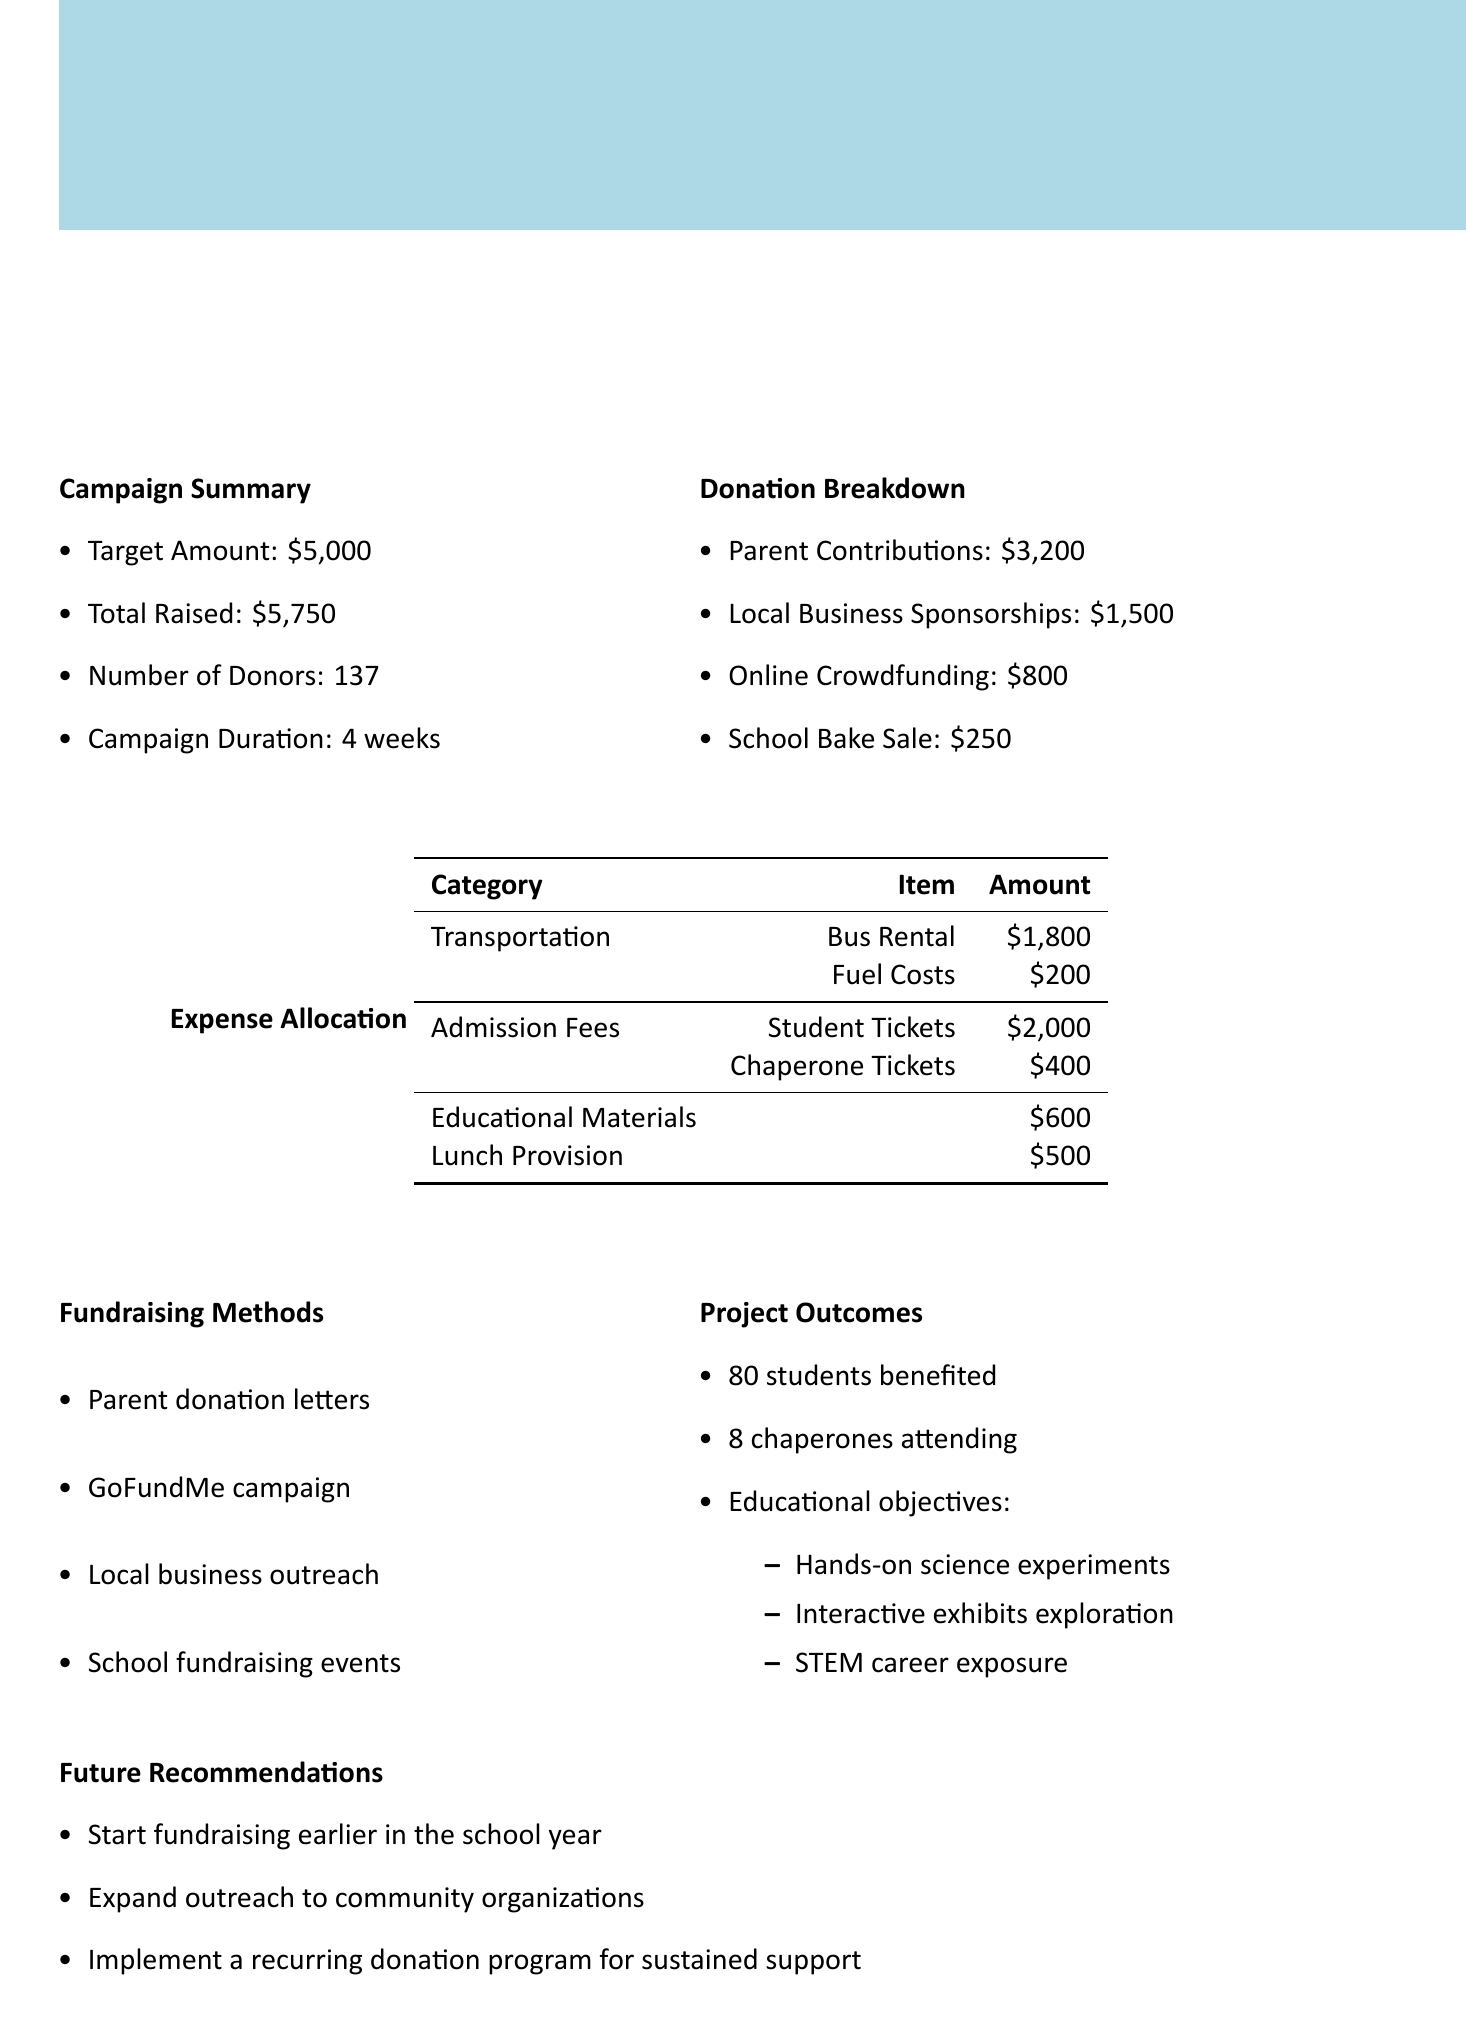what is the target amount for the campaign? The target amount is specified in the campaign summary section of the document.
Answer: $5,000 how much total was raised? The total raised is mentioned directly in the campaign summary section.
Answer: $5,750 how many donors contributed to the campaign? The number of donors is provided in the campaign summary.
Answer: 137 what was the total cost for student tickets? The student ticket cost is broken down under admission fees in the expense allocation section.
Answer: $2,000 what percentage of the total funds raised is allocated for transportation? Transportation costs are part of the total raised, which requires calculating the ratio of transportation expenses to total raised. Total transportation is $2,000, and the total funds raised is $5,750.
Answer: 35% which fundraising method produced the highest amount? The donation breakdown shows the contributions from various sources, indicating which produced the highest amount.
Answer: Parent Contributions how many students benefited from the field trip? The number of students benefited is stated in the project outcomes section.
Answer: 80 what are one of the educational objectives of the trip? The educational objectives are listed in the project outcomes section and can be referenced directly for specific details.
Answer: Hands-on science experiments what is one key future recommendation made in the report? Future recommendations are provided at the end of the document, highlighting suggestions for improvement.
Answer: Start fundraising earlier in the school year 